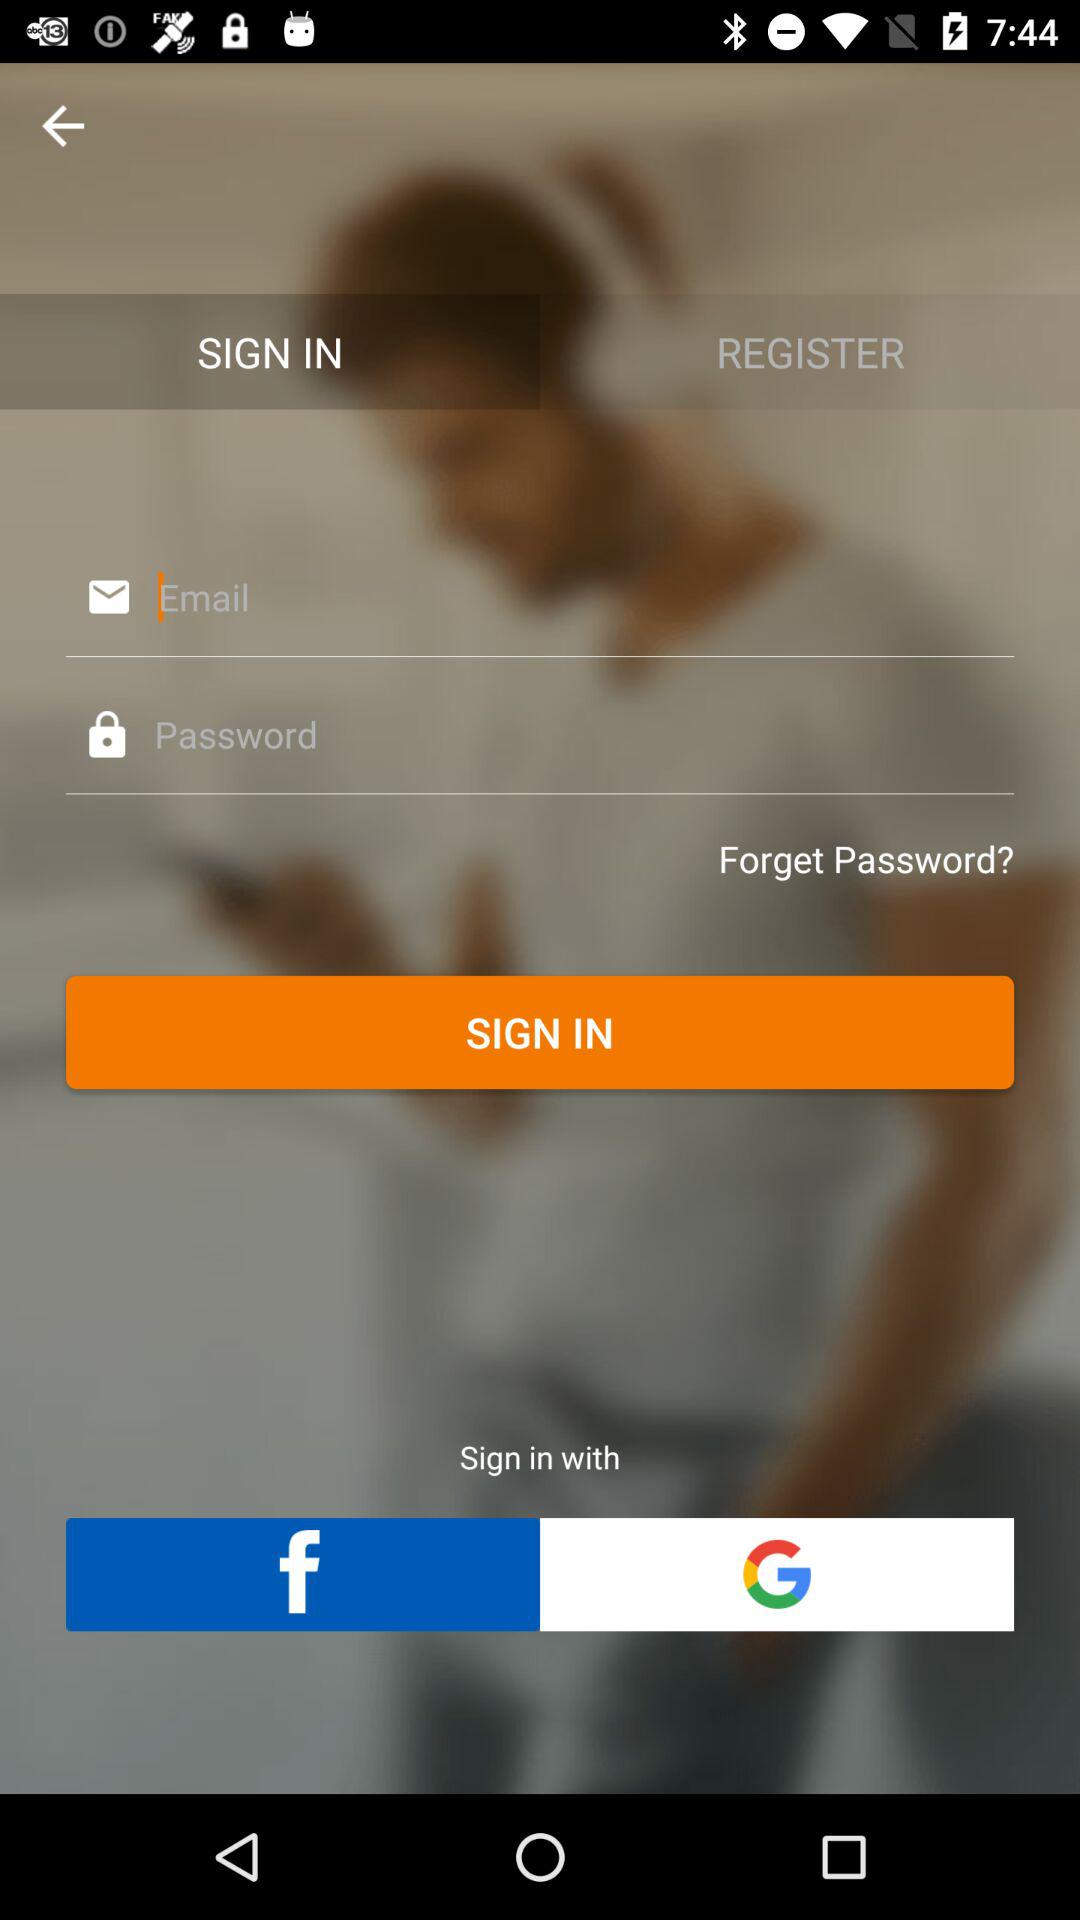What accounts can I use to sign in? You can use "Email", "Facebook" and "Google". 